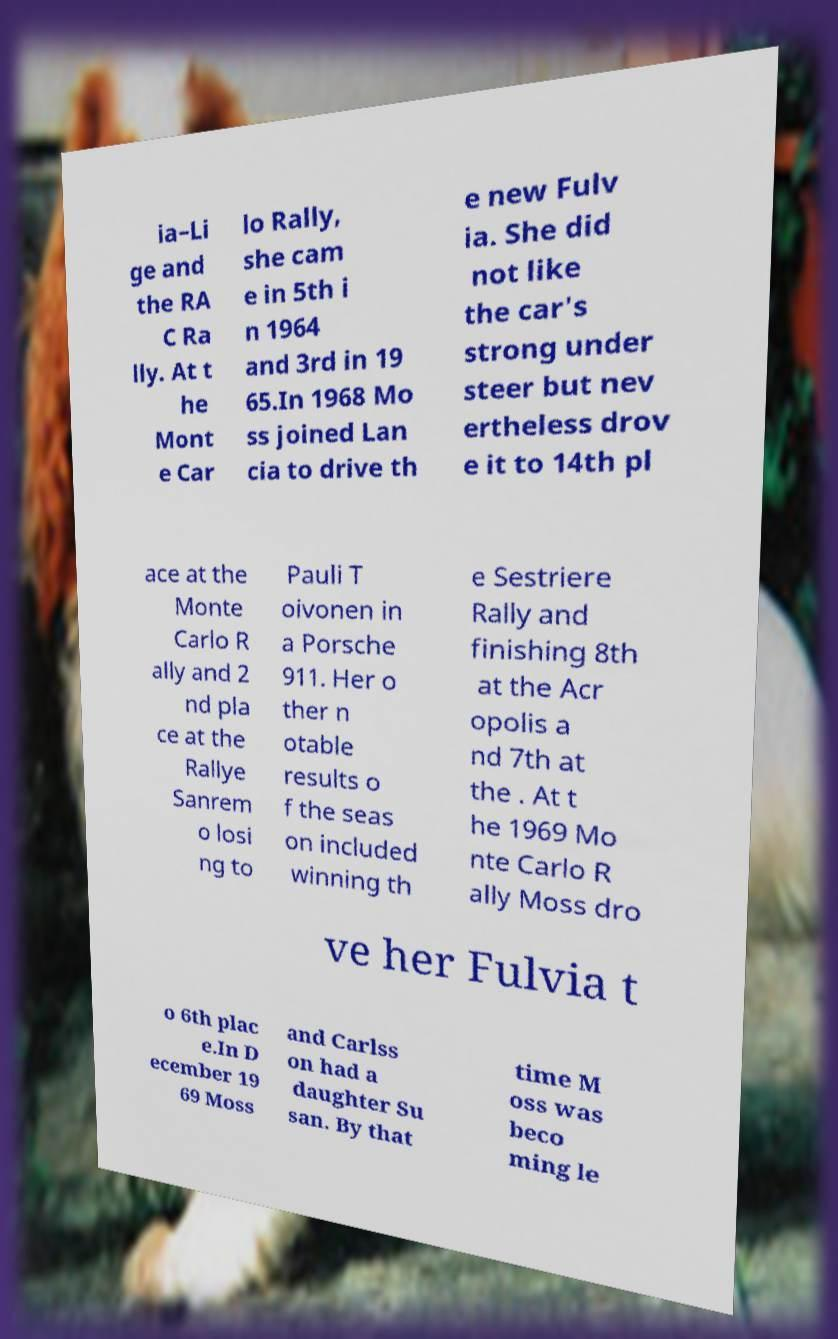Please identify and transcribe the text found in this image. ia–Li ge and the RA C Ra lly. At t he Mont e Car lo Rally, she cam e in 5th i n 1964 and 3rd in 19 65.In 1968 Mo ss joined Lan cia to drive th e new Fulv ia. She did not like the car's strong under steer but nev ertheless drov e it to 14th pl ace at the Monte Carlo R ally and 2 nd pla ce at the Rallye Sanrem o losi ng to Pauli T oivonen in a Porsche 911. Her o ther n otable results o f the seas on included winning th e Sestriere Rally and finishing 8th at the Acr opolis a nd 7th at the . At t he 1969 Mo nte Carlo R ally Moss dro ve her Fulvia t o 6th plac e.In D ecember 19 69 Moss and Carlss on had a daughter Su san. By that time M oss was beco ming le 